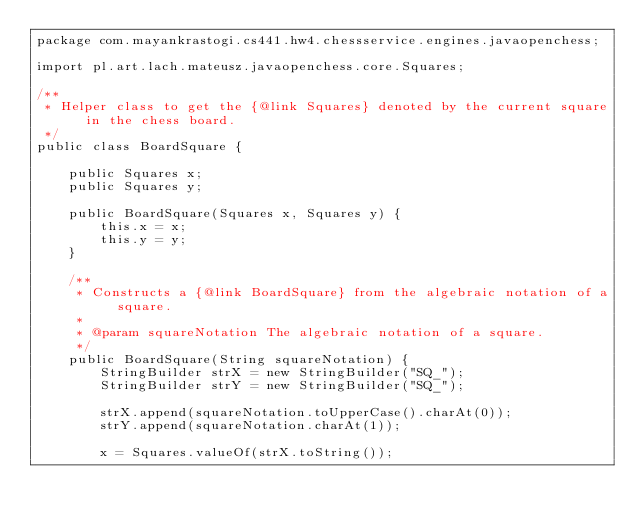Convert code to text. <code><loc_0><loc_0><loc_500><loc_500><_Java_>package com.mayankrastogi.cs441.hw4.chessservice.engines.javaopenchess;

import pl.art.lach.mateusz.javaopenchess.core.Squares;

/**
 * Helper class to get the {@link Squares} denoted by the current square in the chess board.
 */
public class BoardSquare {

    public Squares x;
    public Squares y;

    public BoardSquare(Squares x, Squares y) {
        this.x = x;
        this.y = y;
    }

    /**
     * Constructs a {@link BoardSquare} from the algebraic notation of a square.
     *
     * @param squareNotation The algebraic notation of a square.
     */
    public BoardSquare(String squareNotation) {
        StringBuilder strX = new StringBuilder("SQ_");
        StringBuilder strY = new StringBuilder("SQ_");

        strX.append(squareNotation.toUpperCase().charAt(0));
        strY.append(squareNotation.charAt(1));

        x = Squares.valueOf(strX.toString());</code> 